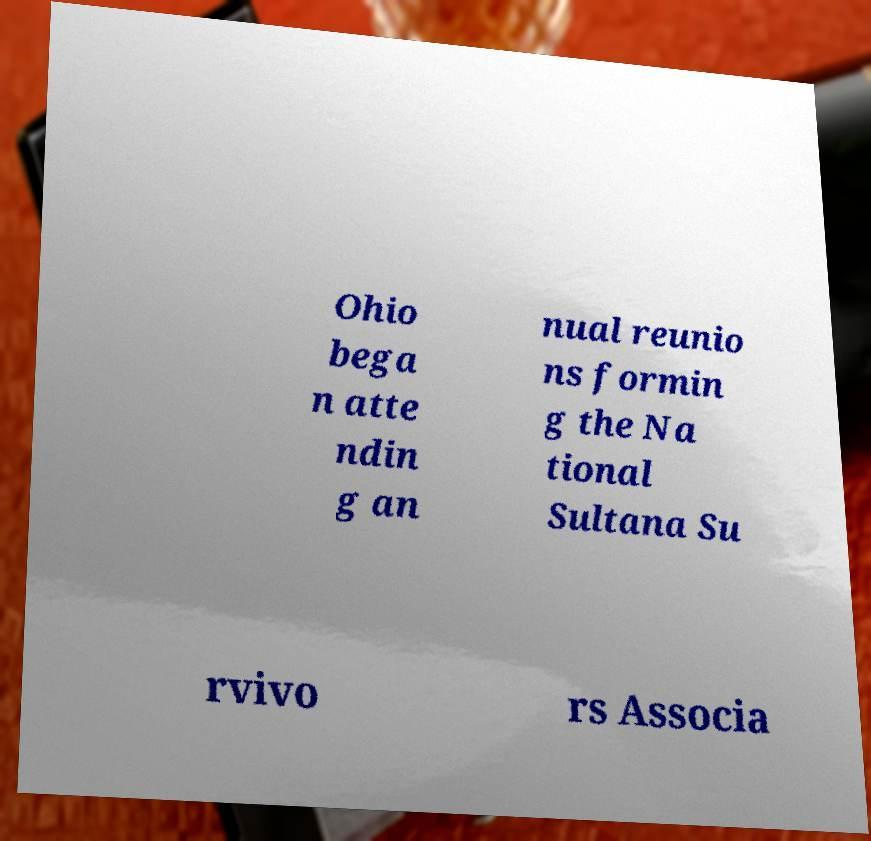Please identify and transcribe the text found in this image. Ohio bega n atte ndin g an nual reunio ns formin g the Na tional Sultana Su rvivo rs Associa 